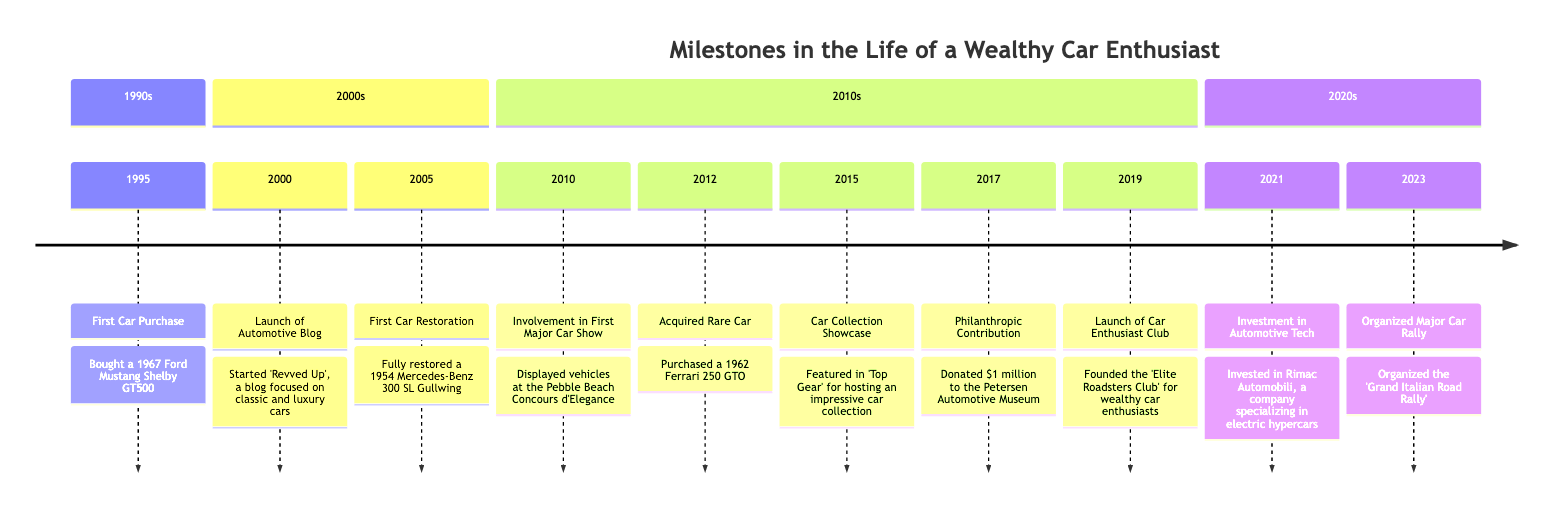What was the first car purchased? The diagram indicates that the first car purchased in 1995 was a 1967 Ford Mustang Shelby GT500.
Answer: 1967 Ford Mustang Shelby GT500 How many years are represented in the timeline? The timeline spans from 1995 to 2023, which is a total of 29 years, covering milestones from 1995 to 2023.
Answer: 29 years What year marked the launch of the automotive blog? According to the timeline, the automotive blog 'Revved Up' was launched in the year 2000.
Answer: 2000 What significant car event occurred in 2017? In the year 2017, the diagram shows a philanthropic contribution of $1 million to the Petersen Automotive Museum.
Answer: $1 million Which car was acquired in 2012? The timeline indicates that in 2012, a 1962 Ferrari 250 GTO was purchased, noted as a rare and valuable car.
Answer: 1962 Ferrari 250 GTO What achievement signifies the first car restoration? The first car restoration achievement was fully restoring a 1954 Mercedes-Benz 300 SL Gullwing in 2005, highlighting the milestone in craftsmanship.
Answer: 1954 Mercedes-Benz 300 SL Gullwing What type of event was organized in 2023? The timeline states that a major car rally named 'Grand Italian Road Rally' was organized in 2023, indicating a significant social event.
Answer: Grand Italian Road Rally How many significant philanthropic contributions are noted? There is 1 significant philanthropic contribution noted in 2017, which was a donation to the Petersen Automotive Museum.
Answer: 1 In which year did the car enthusiast club launch? The Elite Roadsters Club was founded in 2019, which is when the car enthusiast club launched according to the timeline.
Answer: 2019 